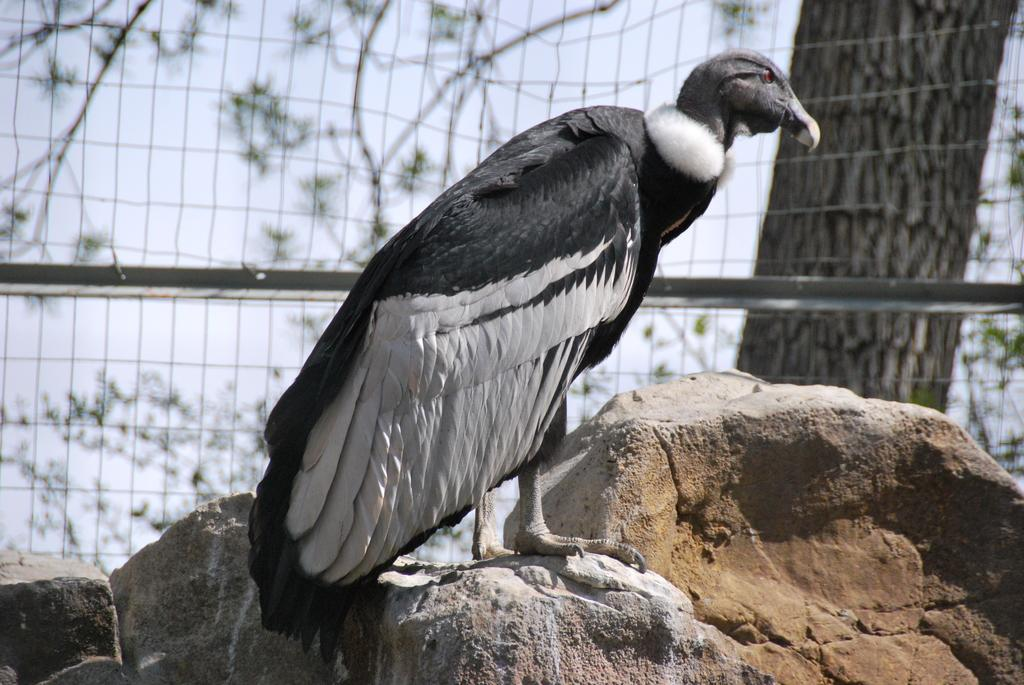What type of animal can be seen in the image? There is a bird in the image. What is visible in the background of the image? There is a mesh and a tree in the background of the image. What type of jam is being used to make the selection in the image? There is no jam or selection process present in the image; it features a bird and a background with mesh and a tree. 